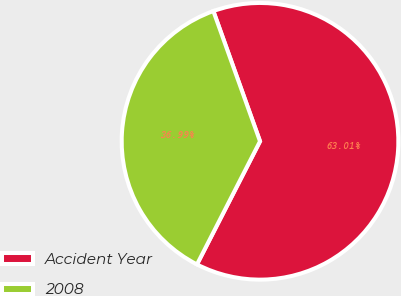Convert chart. <chart><loc_0><loc_0><loc_500><loc_500><pie_chart><fcel>Accident Year<fcel>2008<nl><fcel>63.01%<fcel>36.99%<nl></chart> 